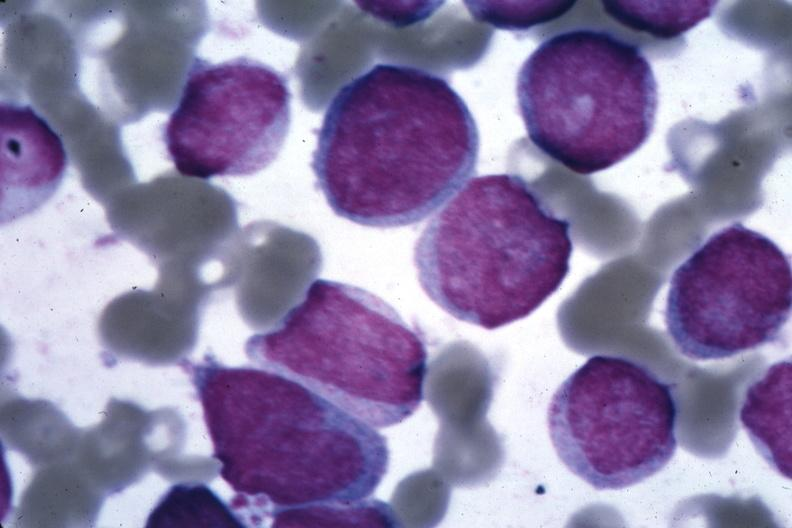does this image show oil wrights cells easily diagnosed?
Answer the question using a single word or phrase. Yes 